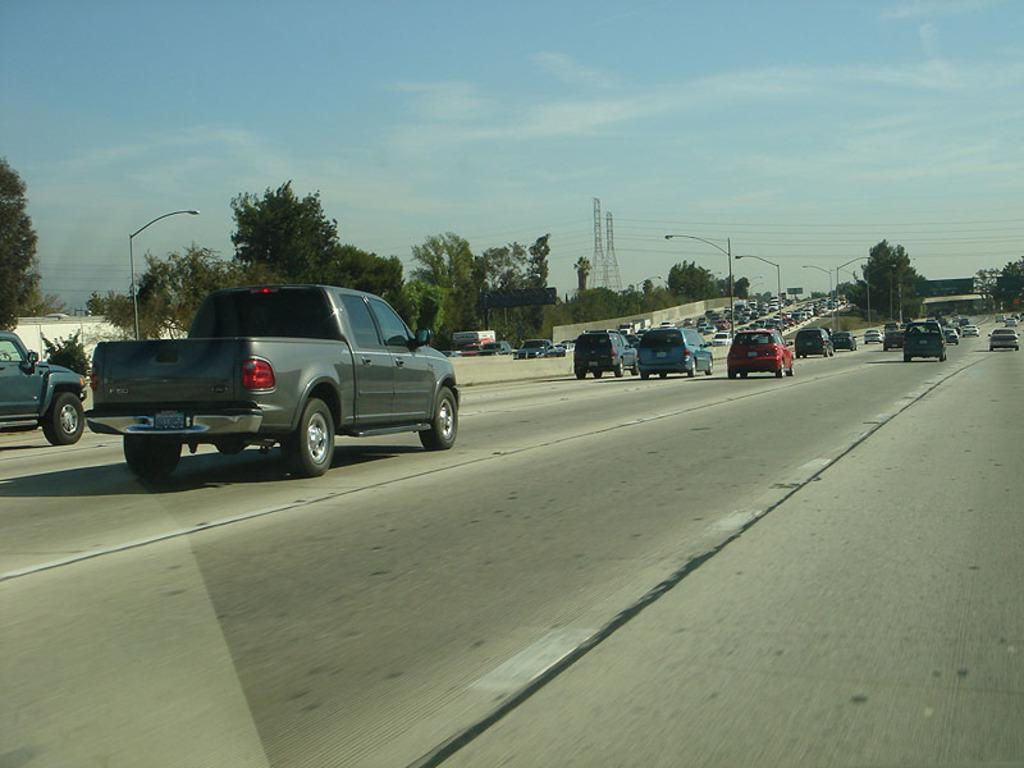What can be seen on the road in the image? There are vehicles on the road in the image. What structures are present in the image? There are poles and trees in the image. How many electric poles are visible in the image? There are 2 electric poles in the image. What is connected to the electric poles? There are wires associated with the electric poles. What is visible at the top of the image? The sky is visible at the top of the image. What type of wool is being used to create the fact in the image? There is no wool or fact present in the image; it features vehicles on the road, poles, trees, electric poles, wires, and the sky. How many brothers are visible in the image? There are no people, let alone brothers, present in the image. 